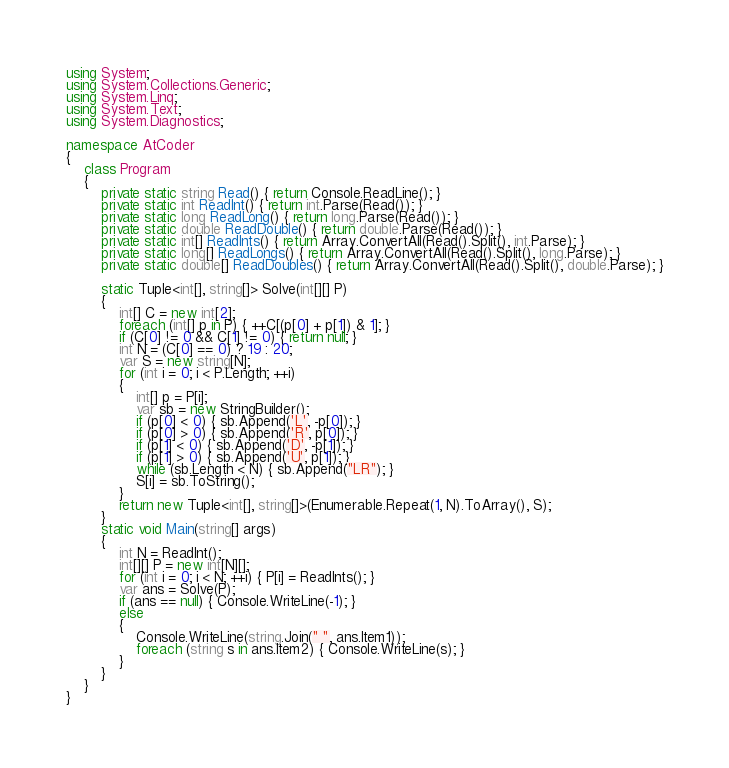<code> <loc_0><loc_0><loc_500><loc_500><_C#_>using System;
using System.Collections.Generic;
using System.Linq;
using System.Text;
using System.Diagnostics;

namespace AtCoder
{
    class Program
    {
        private static string Read() { return Console.ReadLine(); }
        private static int ReadInt() { return int.Parse(Read()); }
        private static long ReadLong() { return long.Parse(Read()); }
        private static double ReadDouble() { return double.Parse(Read()); }
        private static int[] ReadInts() { return Array.ConvertAll(Read().Split(), int.Parse); }
        private static long[] ReadLongs() { return Array.ConvertAll(Read().Split(), long.Parse); }
        private static double[] ReadDoubles() { return Array.ConvertAll(Read().Split(), double.Parse); }

        static Tuple<int[], string[]> Solve(int[][] P)
        {
            int[] C = new int[2];
            foreach (int[] p in P) { ++C[(p[0] + p[1]) & 1]; }
            if (C[0] != 0 && C[1] != 0) { return null; }
            int N = (C[0] == 0) ? 19 : 20;
            var S = new string[N];
            for (int i = 0; i < P.Length; ++i)
            {
                int[] p = P[i];
                var sb = new StringBuilder();
                if (p[0] < 0) { sb.Append('L', -p[0]); }
                if (p[0] > 0) { sb.Append('R', p[0]); }
                if (p[1] < 0) { sb.Append('D', -p[1]); }
                if (p[1] > 0) { sb.Append('U', p[1]); }
                while (sb.Length < N) { sb.Append("LR"); }
                S[i] = sb.ToString();
            }
            return new Tuple<int[], string[]>(Enumerable.Repeat(1, N).ToArray(), S);
        }
        static void Main(string[] args)
        {
            int N = ReadInt();
            int[][] P = new int[N][];
            for (int i = 0; i < N; ++i) { P[i] = ReadInts(); }
            var ans = Solve(P);
            if (ans == null) { Console.WriteLine(-1); }
            else
            {
                Console.WriteLine(string.Join(" ", ans.Item1));
                foreach (string s in ans.Item2) { Console.WriteLine(s); }
            }
        }
    }
}
</code> 